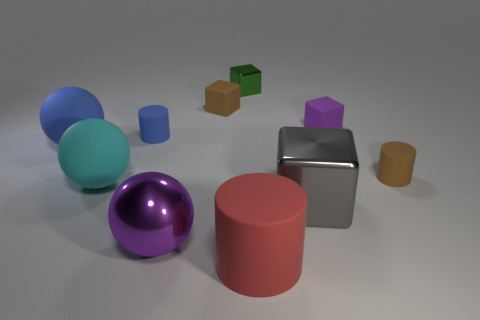Subtract 1 cylinders. How many cylinders are left? 2 Subtract all green balls. Subtract all blue cylinders. How many balls are left? 3 Subtract all purple balls. How many blue cylinders are left? 1 Subtract all cyan matte things. Subtract all red balls. How many objects are left? 9 Add 7 tiny green metal blocks. How many tiny green metal blocks are left? 8 Add 6 shiny objects. How many shiny objects exist? 9 Subtract all purple blocks. How many blocks are left? 3 Subtract all big cubes. How many cubes are left? 3 Subtract 1 red cylinders. How many objects are left? 9 Subtract all cylinders. How many objects are left? 7 